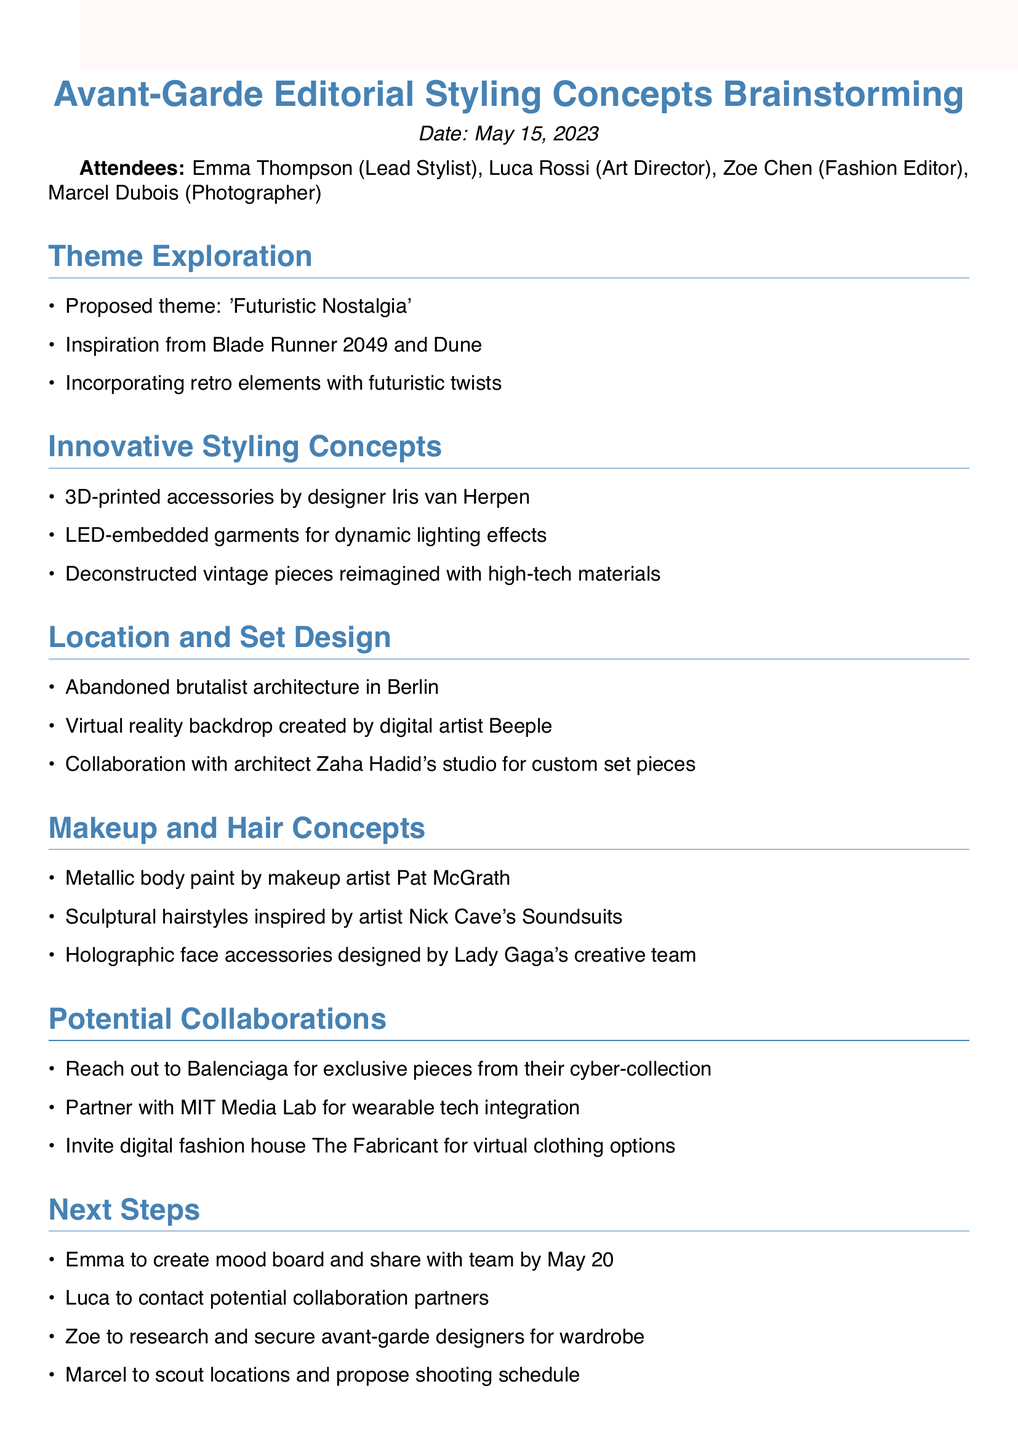What is the proposed theme for the editorial? The proposed theme is a key discussion point in the meeting minutes.
Answer: 'Futuristic Nostalgia' Who is the lead stylist for the session? The lead stylist's name is listed among the attendees.
Answer: Emma Thompson What makeup concept was proposed by Pat McGrath? The specific makeup concept is mentioned under the Makeup and Hair Concepts section.
Answer: Metallic body paint Which city is suggested for the location of the shoot? The location is mentioned under the Location and Set Design section.
Answer: Berlin What is Emma supposed to create by May 20? The action item related to Emma can be found under the Next Steps section.
Answer: Mood board Who is suggested for holographic face accessories? The designer responsible for the accessories is noted in the discussion points.
Answer: Lady Gaga's creative team What type of technology is proposed for garment integration? The type of technology is mentioned under the Potential Collaborations section.
Answer: Wearable tech Which digital artist is suggested for virtual reality backdrops? The name of the digital artist is specified in the Location and Set Design section.
Answer: Beeple What is the date of the brainstorming session? The meeting date is stated at the beginning of the document.
Answer: May 15, 2023 